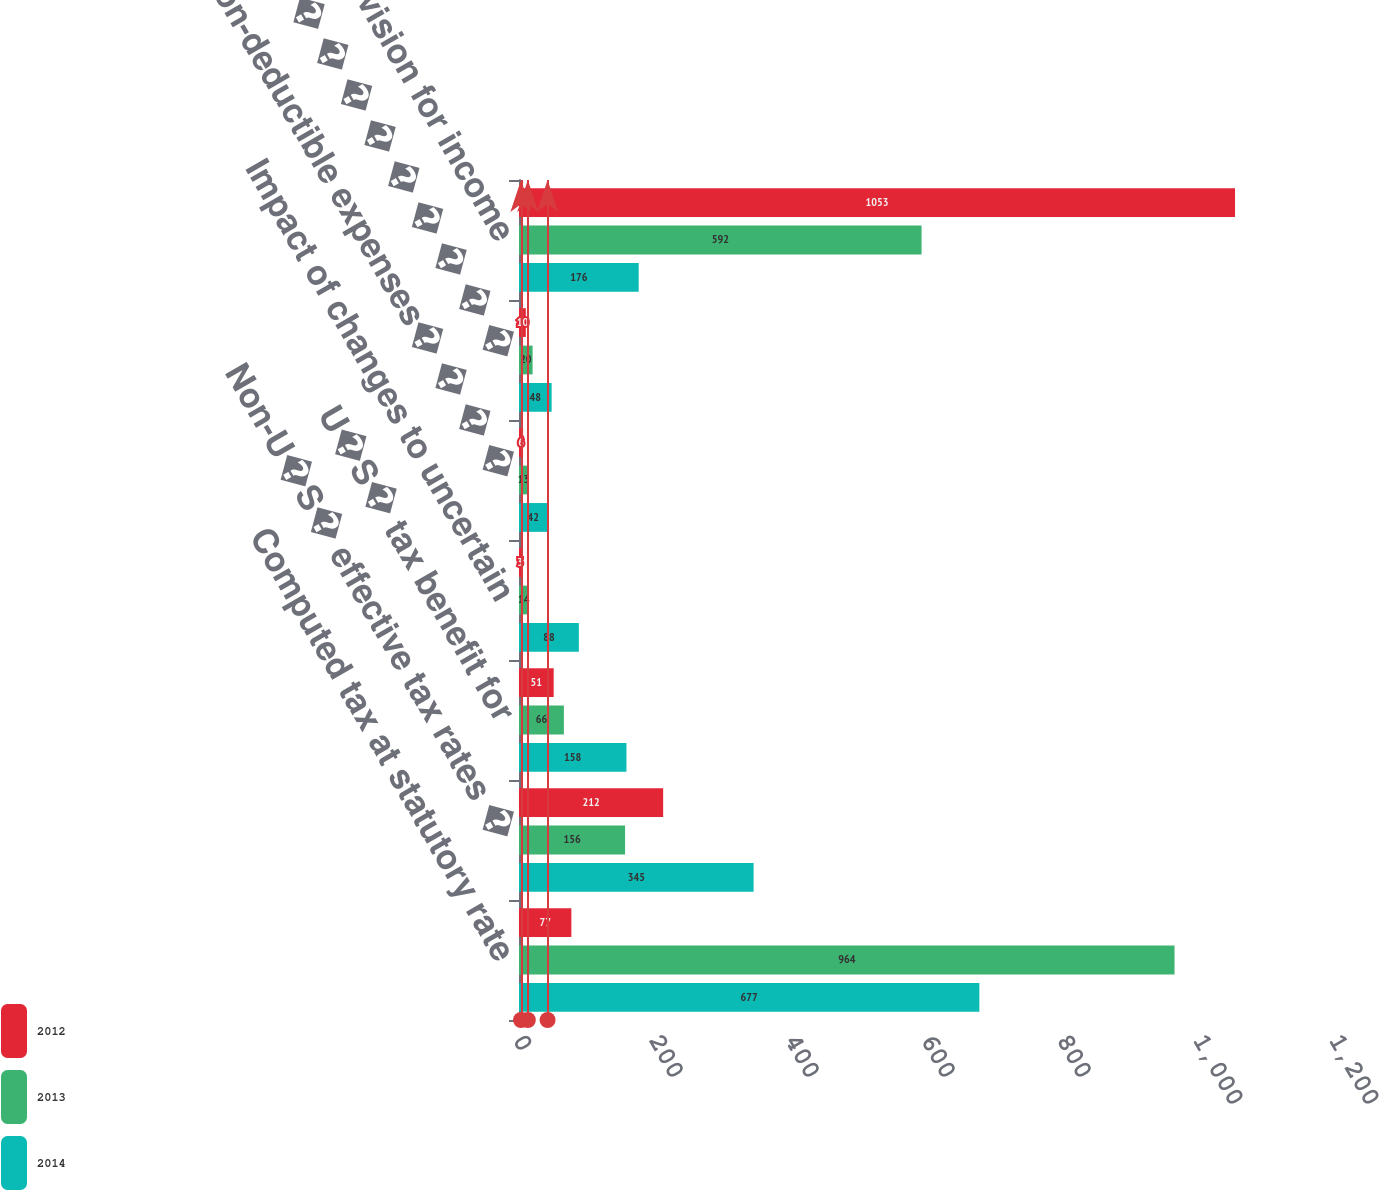Convert chart. <chart><loc_0><loc_0><loc_500><loc_500><stacked_bar_chart><ecel><fcel>Computed tax at statutory rate<fcel>Non-U�S� effective tax rates �<fcel>U�S� tax benefit for<fcel>Impact of changes to uncertain<fcel>Non-deductible expenses� � � �<fcel>Other � � � � � � � � � � � �<fcel>Total provision for income<nl><fcel>2012<fcel>77<fcel>212<fcel>51<fcel>3<fcel>6<fcel>10<fcel>1053<nl><fcel>2013<fcel>964<fcel>156<fcel>66<fcel>14<fcel>13<fcel>20<fcel>592<nl><fcel>2014<fcel>677<fcel>345<fcel>158<fcel>88<fcel>42<fcel>48<fcel>176<nl></chart> 